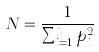<formula> <loc_0><loc_0><loc_500><loc_500>N = \frac { 1 } { \sum _ { i = 1 } ^ { n } p _ { i } ^ { 2 } }</formula> 